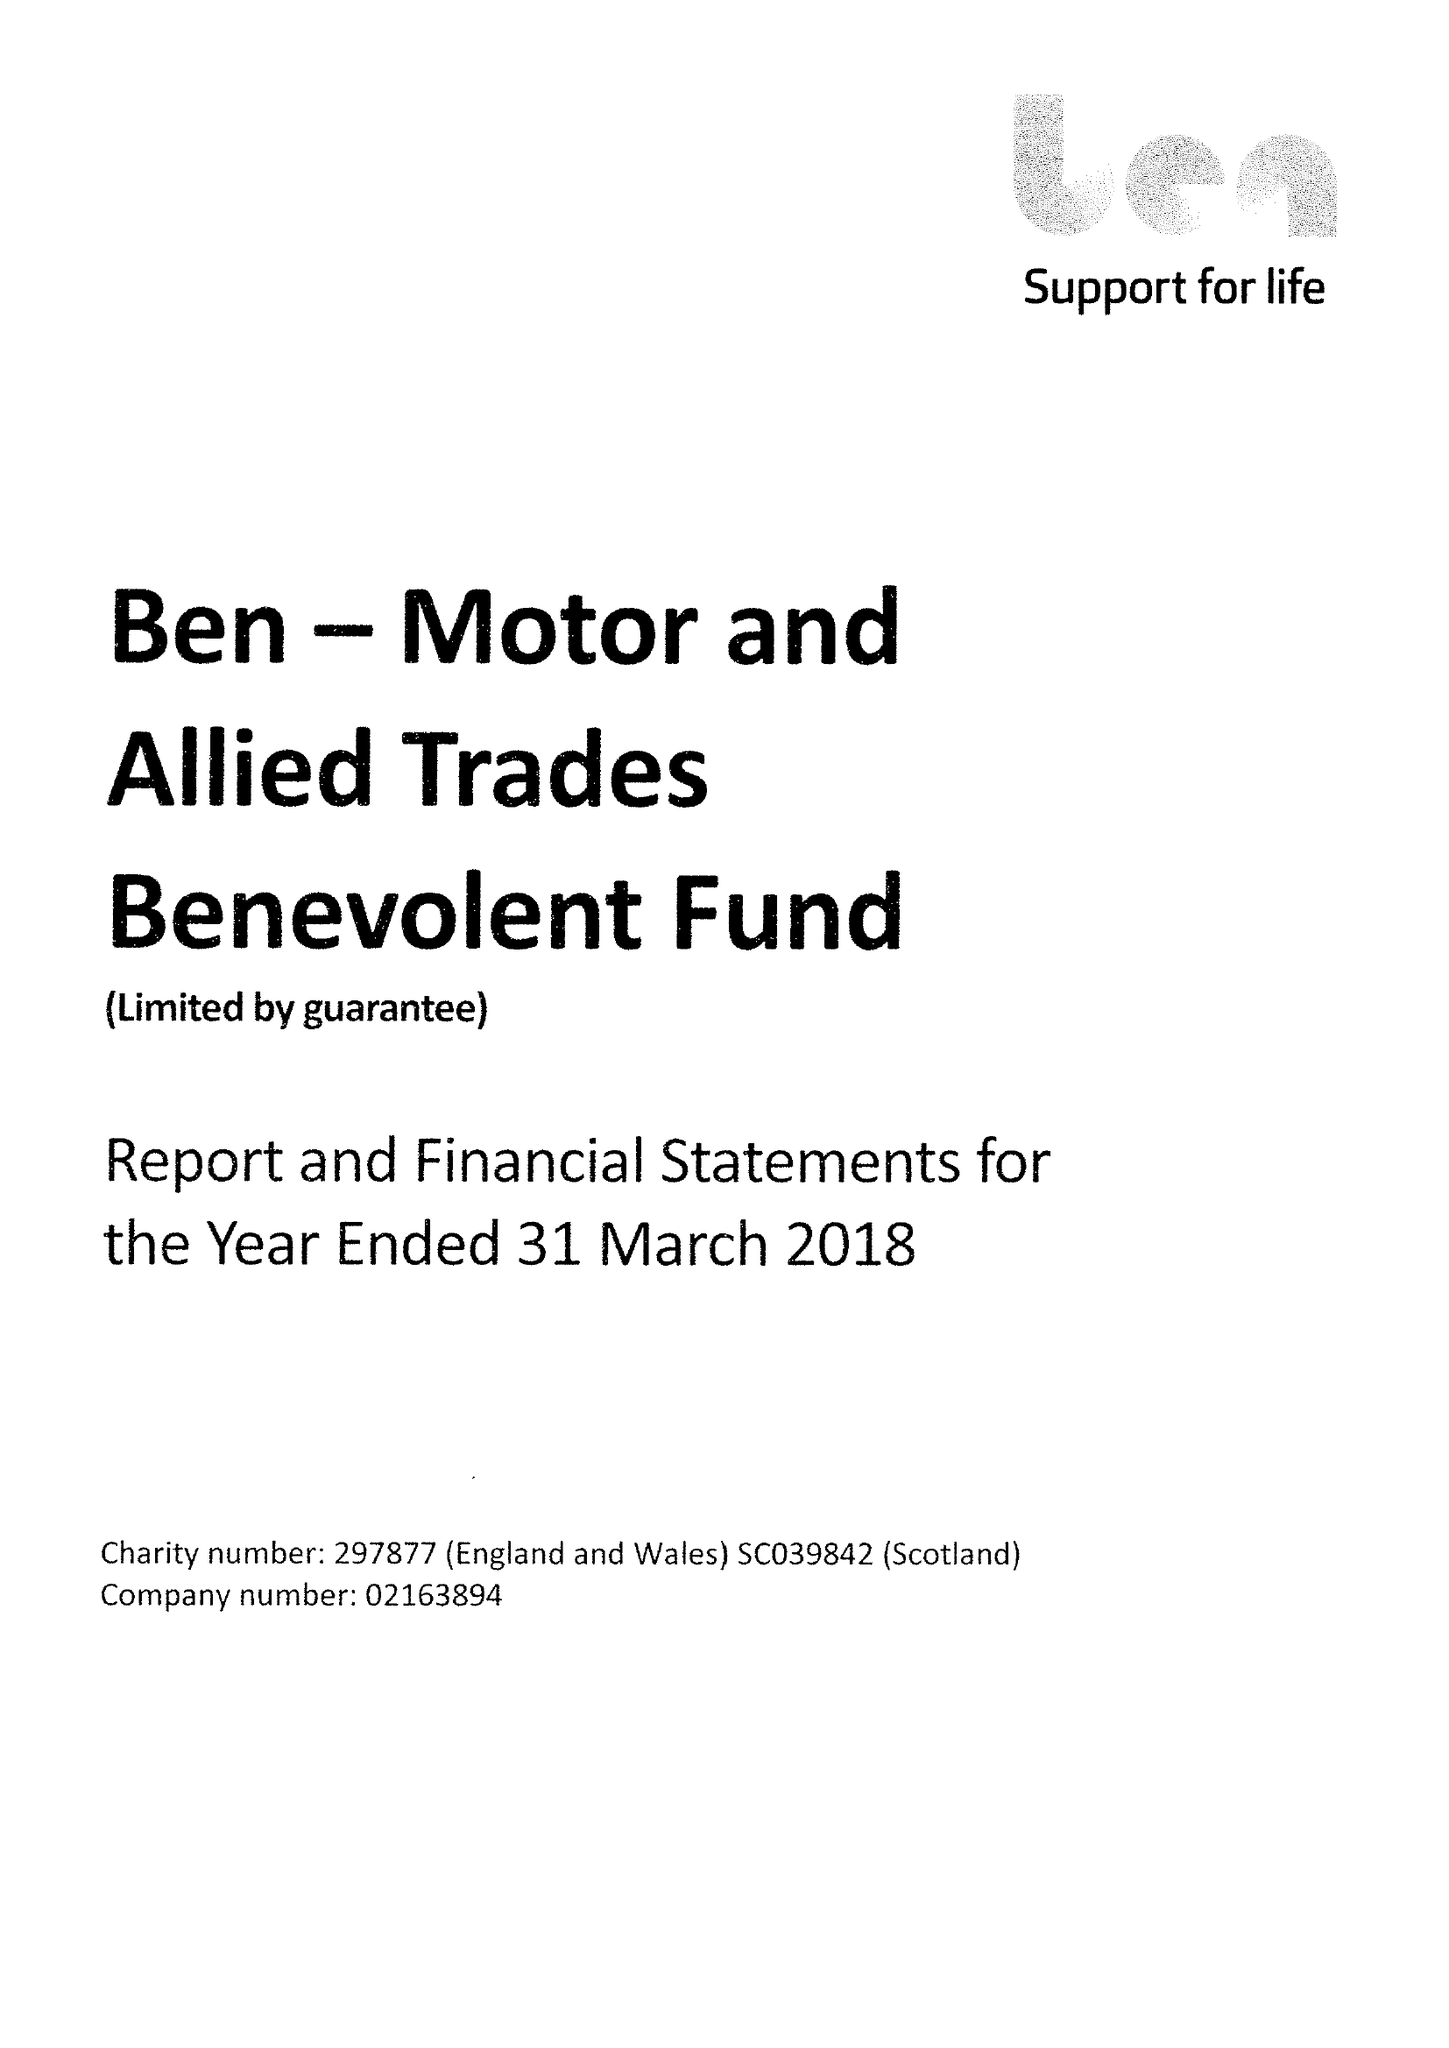What is the value for the charity_name?
Answer the question using a single word or phrase. Ben - Motor and Allied Trades Benevolent Fund 